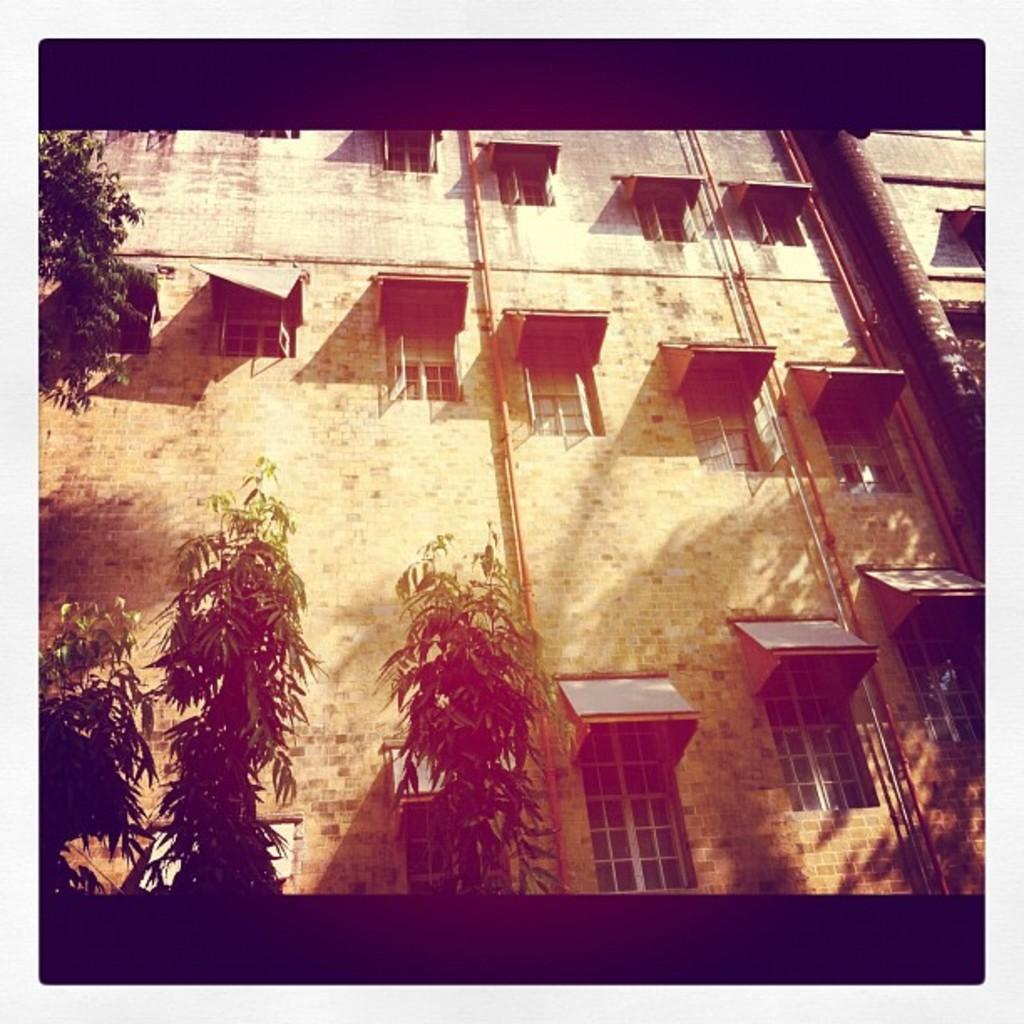What type of structure is visible in the image? There is a building in the image. What features can be seen on the building? The building has windows and pipes. What is located in front of the building? There are trees in front of the building. What position does the coach hold in the library, as seen in the image? There is no coach or library present in the image; it features a building with windows and pipes, and trees in front of it. 